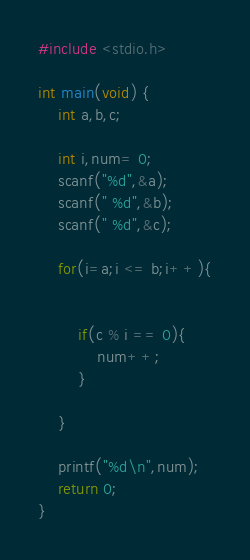Convert code to text. <code><loc_0><loc_0><loc_500><loc_500><_C_>#include <stdio.h>
 
int main(void) {
    int a,b,c;
 
    int i,num= 0;
    scanf("%d",&a);
    scanf(" %d",&b);
    scanf(" %d",&c);
     
    for(i=a;i <= b;i++){
         
     
        if(c % i == 0){
            num++;
        }
     
    }
     
    printf("%d\n",num);
    return 0;
}</code> 